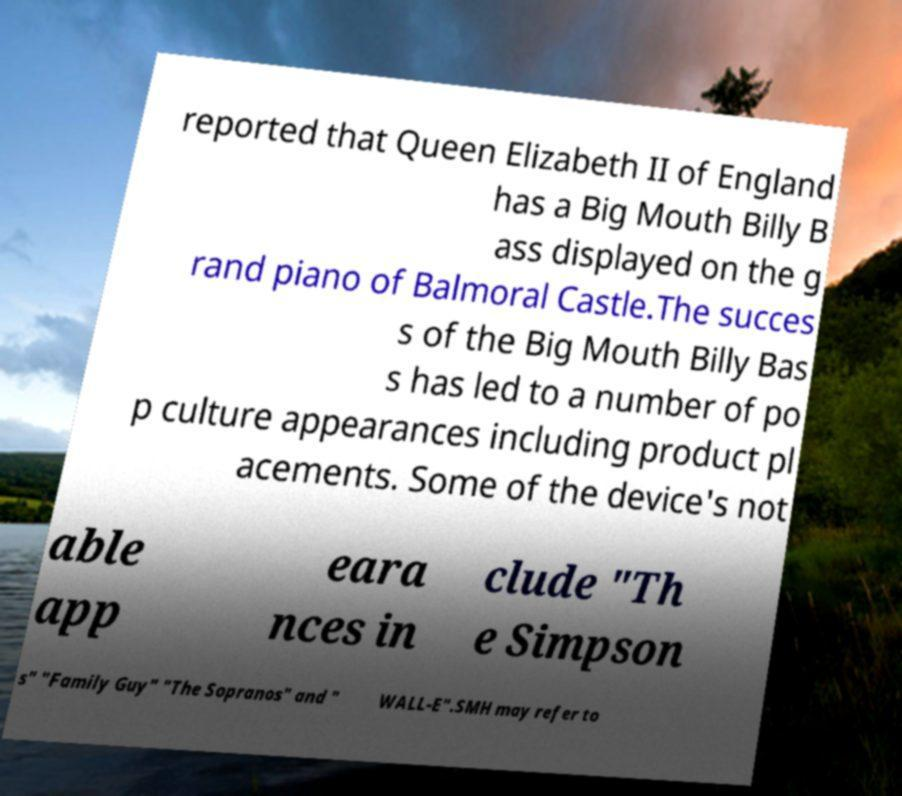Can you read and provide the text displayed in the image?This photo seems to have some interesting text. Can you extract and type it out for me? reported that Queen Elizabeth II of England has a Big Mouth Billy B ass displayed on the g rand piano of Balmoral Castle.The succes s of the Big Mouth Billy Bas s has led to a number of po p culture appearances including product pl acements. Some of the device's not able app eara nces in clude "Th e Simpson s" "Family Guy" "The Sopranos" and " WALL-E".SMH may refer to 